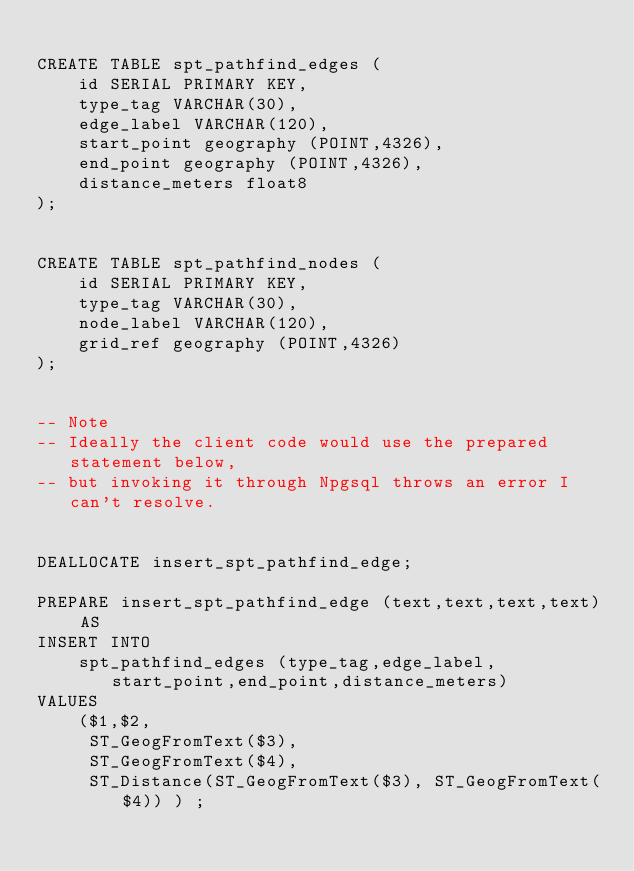<code> <loc_0><loc_0><loc_500><loc_500><_SQL_>
CREATE TABLE spt_pathfind_edges (
    id SERIAL PRIMARY KEY,
    type_tag VARCHAR(30), 
    edge_label VARCHAR(120), 
    start_point geography (POINT,4326), 
    end_point geography (POINT,4326),
    distance_meters float8
);


CREATE TABLE spt_pathfind_nodes (
    id SERIAL PRIMARY KEY,
    type_tag VARCHAR(30), 
    node_label VARCHAR(120), 
    grid_ref geography (POINT,4326)
);


-- Note 
-- Ideally the client code would use the prepared statement below, 
-- but invoking it through Npgsql throws an error I can't resolve.


DEALLOCATE insert_spt_pathfind_edge;

PREPARE insert_spt_pathfind_edge (text,text,text,text) AS
INSERT INTO 
    spt_pathfind_edges (type_tag,edge_label,start_point,end_point,distance_meters) 
VALUES
    ($1,$2,
     ST_GeogFromText($3),
     ST_GeogFromText($4),
     ST_Distance(ST_GeogFromText($3), ST_GeogFromText($4)) ) ;</code> 